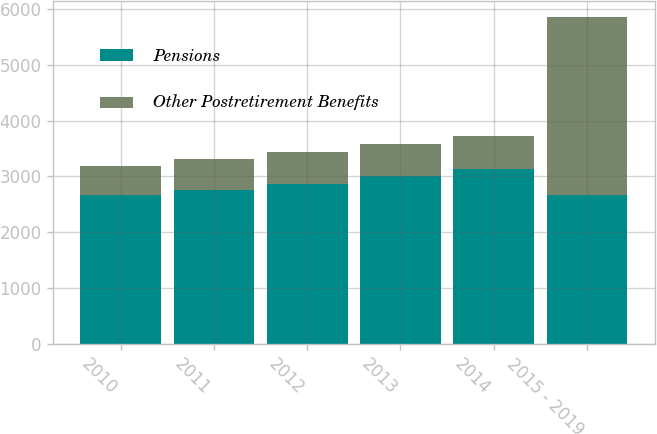Convert chart to OTSL. <chart><loc_0><loc_0><loc_500><loc_500><stacked_bar_chart><ecel><fcel>2010<fcel>2011<fcel>2012<fcel>2013<fcel>2014<fcel>2015 - 2019<nl><fcel>Pensions<fcel>2665<fcel>2764<fcel>2872<fcel>3008<fcel>3130<fcel>2665<nl><fcel>Other Postretirement Benefits<fcel>527<fcel>551<fcel>562<fcel>577<fcel>592<fcel>3188<nl></chart> 